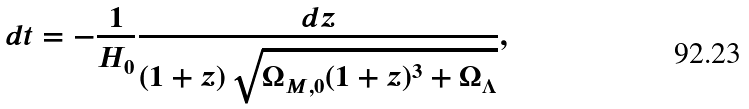Convert formula to latex. <formula><loc_0><loc_0><loc_500><loc_500>d t = - \frac { 1 } { H _ { 0 } } \frac { d z } { \left ( 1 + z \right ) \sqrt { \Omega _ { M , 0 } ( 1 + z ) ^ { 3 } + \Omega _ { \Lambda } } } ,</formula> 